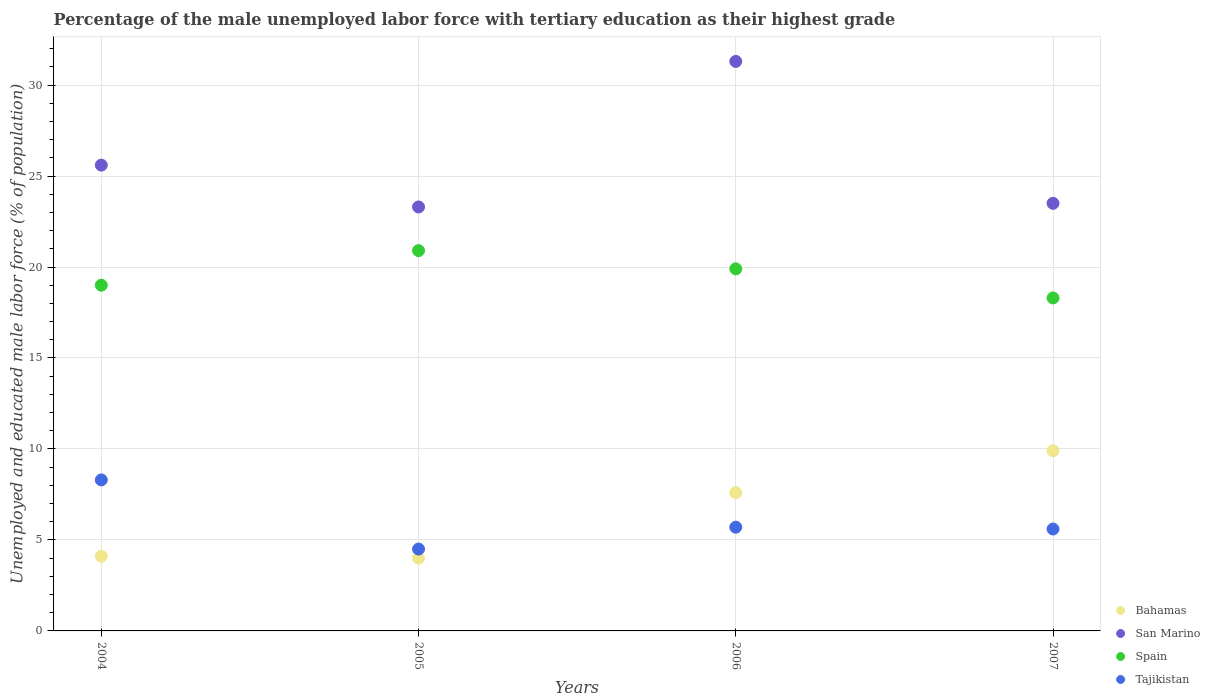What is the percentage of the unemployed male labor force with tertiary education in Spain in 2004?
Offer a very short reply. 19. Across all years, what is the maximum percentage of the unemployed male labor force with tertiary education in Bahamas?
Offer a very short reply. 9.9. Across all years, what is the minimum percentage of the unemployed male labor force with tertiary education in Spain?
Provide a short and direct response. 18.3. In which year was the percentage of the unemployed male labor force with tertiary education in Spain minimum?
Your response must be concise. 2007. What is the total percentage of the unemployed male labor force with tertiary education in San Marino in the graph?
Your answer should be compact. 103.7. What is the difference between the percentage of the unemployed male labor force with tertiary education in Spain in 2004 and that in 2006?
Offer a terse response. -0.9. What is the difference between the percentage of the unemployed male labor force with tertiary education in San Marino in 2006 and the percentage of the unemployed male labor force with tertiary education in Bahamas in 2005?
Ensure brevity in your answer.  27.3. What is the average percentage of the unemployed male labor force with tertiary education in San Marino per year?
Provide a succinct answer. 25.92. In the year 2005, what is the difference between the percentage of the unemployed male labor force with tertiary education in San Marino and percentage of the unemployed male labor force with tertiary education in Spain?
Offer a terse response. 2.4. In how many years, is the percentage of the unemployed male labor force with tertiary education in Tajikistan greater than 31 %?
Keep it short and to the point. 0. What is the ratio of the percentage of the unemployed male labor force with tertiary education in Spain in 2004 to that in 2006?
Ensure brevity in your answer.  0.95. What is the difference between the highest and the second highest percentage of the unemployed male labor force with tertiary education in Tajikistan?
Make the answer very short. 2.6. What is the difference between the highest and the lowest percentage of the unemployed male labor force with tertiary education in San Marino?
Provide a short and direct response. 8. In how many years, is the percentage of the unemployed male labor force with tertiary education in San Marino greater than the average percentage of the unemployed male labor force with tertiary education in San Marino taken over all years?
Give a very brief answer. 1. Is the percentage of the unemployed male labor force with tertiary education in San Marino strictly less than the percentage of the unemployed male labor force with tertiary education in Bahamas over the years?
Offer a terse response. No. How many dotlines are there?
Offer a very short reply. 4. Does the graph contain any zero values?
Ensure brevity in your answer.  No. Does the graph contain grids?
Your answer should be very brief. Yes. Where does the legend appear in the graph?
Your answer should be very brief. Bottom right. How are the legend labels stacked?
Provide a short and direct response. Vertical. What is the title of the graph?
Provide a short and direct response. Percentage of the male unemployed labor force with tertiary education as their highest grade. What is the label or title of the X-axis?
Give a very brief answer. Years. What is the label or title of the Y-axis?
Provide a short and direct response. Unemployed and educated male labor force (% of population). What is the Unemployed and educated male labor force (% of population) of Bahamas in 2004?
Ensure brevity in your answer.  4.1. What is the Unemployed and educated male labor force (% of population) in San Marino in 2004?
Your answer should be compact. 25.6. What is the Unemployed and educated male labor force (% of population) of Spain in 2004?
Make the answer very short. 19. What is the Unemployed and educated male labor force (% of population) of Tajikistan in 2004?
Offer a very short reply. 8.3. What is the Unemployed and educated male labor force (% of population) in Bahamas in 2005?
Give a very brief answer. 4. What is the Unemployed and educated male labor force (% of population) in San Marino in 2005?
Ensure brevity in your answer.  23.3. What is the Unemployed and educated male labor force (% of population) in Spain in 2005?
Provide a succinct answer. 20.9. What is the Unemployed and educated male labor force (% of population) of Tajikistan in 2005?
Ensure brevity in your answer.  4.5. What is the Unemployed and educated male labor force (% of population) of Bahamas in 2006?
Keep it short and to the point. 7.6. What is the Unemployed and educated male labor force (% of population) in San Marino in 2006?
Give a very brief answer. 31.3. What is the Unemployed and educated male labor force (% of population) in Spain in 2006?
Your answer should be very brief. 19.9. What is the Unemployed and educated male labor force (% of population) of Tajikistan in 2006?
Your answer should be very brief. 5.7. What is the Unemployed and educated male labor force (% of population) in Bahamas in 2007?
Provide a succinct answer. 9.9. What is the Unemployed and educated male labor force (% of population) of San Marino in 2007?
Provide a short and direct response. 23.5. What is the Unemployed and educated male labor force (% of population) of Spain in 2007?
Ensure brevity in your answer.  18.3. What is the Unemployed and educated male labor force (% of population) of Tajikistan in 2007?
Your response must be concise. 5.6. Across all years, what is the maximum Unemployed and educated male labor force (% of population) of Bahamas?
Give a very brief answer. 9.9. Across all years, what is the maximum Unemployed and educated male labor force (% of population) of San Marino?
Make the answer very short. 31.3. Across all years, what is the maximum Unemployed and educated male labor force (% of population) in Spain?
Keep it short and to the point. 20.9. Across all years, what is the maximum Unemployed and educated male labor force (% of population) of Tajikistan?
Ensure brevity in your answer.  8.3. Across all years, what is the minimum Unemployed and educated male labor force (% of population) in Bahamas?
Offer a terse response. 4. Across all years, what is the minimum Unemployed and educated male labor force (% of population) in San Marino?
Ensure brevity in your answer.  23.3. Across all years, what is the minimum Unemployed and educated male labor force (% of population) of Spain?
Ensure brevity in your answer.  18.3. Across all years, what is the minimum Unemployed and educated male labor force (% of population) in Tajikistan?
Your answer should be compact. 4.5. What is the total Unemployed and educated male labor force (% of population) in Bahamas in the graph?
Offer a very short reply. 25.6. What is the total Unemployed and educated male labor force (% of population) in San Marino in the graph?
Provide a succinct answer. 103.7. What is the total Unemployed and educated male labor force (% of population) in Spain in the graph?
Ensure brevity in your answer.  78.1. What is the total Unemployed and educated male labor force (% of population) in Tajikistan in the graph?
Make the answer very short. 24.1. What is the difference between the Unemployed and educated male labor force (% of population) of San Marino in 2004 and that in 2005?
Your answer should be very brief. 2.3. What is the difference between the Unemployed and educated male labor force (% of population) in Bahamas in 2004 and that in 2006?
Your answer should be compact. -3.5. What is the difference between the Unemployed and educated male labor force (% of population) in San Marino in 2004 and that in 2006?
Keep it short and to the point. -5.7. What is the difference between the Unemployed and educated male labor force (% of population) of Tajikistan in 2004 and that in 2006?
Keep it short and to the point. 2.6. What is the difference between the Unemployed and educated male labor force (% of population) of Tajikistan in 2004 and that in 2007?
Give a very brief answer. 2.7. What is the difference between the Unemployed and educated male labor force (% of population) of San Marino in 2005 and that in 2006?
Offer a terse response. -8. What is the difference between the Unemployed and educated male labor force (% of population) in Spain in 2005 and that in 2006?
Make the answer very short. 1. What is the difference between the Unemployed and educated male labor force (% of population) of Tajikistan in 2005 and that in 2006?
Your response must be concise. -1.2. What is the difference between the Unemployed and educated male labor force (% of population) of Tajikistan in 2005 and that in 2007?
Ensure brevity in your answer.  -1.1. What is the difference between the Unemployed and educated male labor force (% of population) of Bahamas in 2006 and that in 2007?
Offer a terse response. -2.3. What is the difference between the Unemployed and educated male labor force (% of population) of San Marino in 2006 and that in 2007?
Your answer should be compact. 7.8. What is the difference between the Unemployed and educated male labor force (% of population) of Spain in 2006 and that in 2007?
Provide a short and direct response. 1.6. What is the difference between the Unemployed and educated male labor force (% of population) in Tajikistan in 2006 and that in 2007?
Keep it short and to the point. 0.1. What is the difference between the Unemployed and educated male labor force (% of population) of Bahamas in 2004 and the Unemployed and educated male labor force (% of population) of San Marino in 2005?
Offer a terse response. -19.2. What is the difference between the Unemployed and educated male labor force (% of population) in Bahamas in 2004 and the Unemployed and educated male labor force (% of population) in Spain in 2005?
Keep it short and to the point. -16.8. What is the difference between the Unemployed and educated male labor force (% of population) in San Marino in 2004 and the Unemployed and educated male labor force (% of population) in Spain in 2005?
Your response must be concise. 4.7. What is the difference between the Unemployed and educated male labor force (% of population) in San Marino in 2004 and the Unemployed and educated male labor force (% of population) in Tajikistan in 2005?
Ensure brevity in your answer.  21.1. What is the difference between the Unemployed and educated male labor force (% of population) of Spain in 2004 and the Unemployed and educated male labor force (% of population) of Tajikistan in 2005?
Make the answer very short. 14.5. What is the difference between the Unemployed and educated male labor force (% of population) of Bahamas in 2004 and the Unemployed and educated male labor force (% of population) of San Marino in 2006?
Give a very brief answer. -27.2. What is the difference between the Unemployed and educated male labor force (% of population) in Bahamas in 2004 and the Unemployed and educated male labor force (% of population) in Spain in 2006?
Provide a short and direct response. -15.8. What is the difference between the Unemployed and educated male labor force (% of population) in Bahamas in 2004 and the Unemployed and educated male labor force (% of population) in Tajikistan in 2006?
Keep it short and to the point. -1.6. What is the difference between the Unemployed and educated male labor force (% of population) of San Marino in 2004 and the Unemployed and educated male labor force (% of population) of Spain in 2006?
Give a very brief answer. 5.7. What is the difference between the Unemployed and educated male labor force (% of population) in Bahamas in 2004 and the Unemployed and educated male labor force (% of population) in San Marino in 2007?
Provide a succinct answer. -19.4. What is the difference between the Unemployed and educated male labor force (% of population) in Bahamas in 2004 and the Unemployed and educated male labor force (% of population) in Spain in 2007?
Your answer should be very brief. -14.2. What is the difference between the Unemployed and educated male labor force (% of population) of Bahamas in 2004 and the Unemployed and educated male labor force (% of population) of Tajikistan in 2007?
Make the answer very short. -1.5. What is the difference between the Unemployed and educated male labor force (% of population) in San Marino in 2004 and the Unemployed and educated male labor force (% of population) in Tajikistan in 2007?
Offer a very short reply. 20. What is the difference between the Unemployed and educated male labor force (% of population) of Spain in 2004 and the Unemployed and educated male labor force (% of population) of Tajikistan in 2007?
Provide a succinct answer. 13.4. What is the difference between the Unemployed and educated male labor force (% of population) of Bahamas in 2005 and the Unemployed and educated male labor force (% of population) of San Marino in 2006?
Ensure brevity in your answer.  -27.3. What is the difference between the Unemployed and educated male labor force (% of population) in Bahamas in 2005 and the Unemployed and educated male labor force (% of population) in Spain in 2006?
Give a very brief answer. -15.9. What is the difference between the Unemployed and educated male labor force (% of population) in Bahamas in 2005 and the Unemployed and educated male labor force (% of population) in Tajikistan in 2006?
Your answer should be compact. -1.7. What is the difference between the Unemployed and educated male labor force (% of population) of San Marino in 2005 and the Unemployed and educated male labor force (% of population) of Spain in 2006?
Offer a very short reply. 3.4. What is the difference between the Unemployed and educated male labor force (% of population) of San Marino in 2005 and the Unemployed and educated male labor force (% of population) of Tajikistan in 2006?
Provide a short and direct response. 17.6. What is the difference between the Unemployed and educated male labor force (% of population) of Spain in 2005 and the Unemployed and educated male labor force (% of population) of Tajikistan in 2006?
Provide a succinct answer. 15.2. What is the difference between the Unemployed and educated male labor force (% of population) of Bahamas in 2005 and the Unemployed and educated male labor force (% of population) of San Marino in 2007?
Offer a very short reply. -19.5. What is the difference between the Unemployed and educated male labor force (% of population) of Bahamas in 2005 and the Unemployed and educated male labor force (% of population) of Spain in 2007?
Keep it short and to the point. -14.3. What is the difference between the Unemployed and educated male labor force (% of population) in Bahamas in 2005 and the Unemployed and educated male labor force (% of population) in Tajikistan in 2007?
Keep it short and to the point. -1.6. What is the difference between the Unemployed and educated male labor force (% of population) in San Marino in 2005 and the Unemployed and educated male labor force (% of population) in Tajikistan in 2007?
Make the answer very short. 17.7. What is the difference between the Unemployed and educated male labor force (% of population) in Spain in 2005 and the Unemployed and educated male labor force (% of population) in Tajikistan in 2007?
Offer a terse response. 15.3. What is the difference between the Unemployed and educated male labor force (% of population) of Bahamas in 2006 and the Unemployed and educated male labor force (% of population) of San Marino in 2007?
Your answer should be very brief. -15.9. What is the difference between the Unemployed and educated male labor force (% of population) in Bahamas in 2006 and the Unemployed and educated male labor force (% of population) in Tajikistan in 2007?
Offer a very short reply. 2. What is the difference between the Unemployed and educated male labor force (% of population) in San Marino in 2006 and the Unemployed and educated male labor force (% of population) in Tajikistan in 2007?
Keep it short and to the point. 25.7. What is the average Unemployed and educated male labor force (% of population) in Bahamas per year?
Offer a very short reply. 6.4. What is the average Unemployed and educated male labor force (% of population) of San Marino per year?
Your response must be concise. 25.93. What is the average Unemployed and educated male labor force (% of population) in Spain per year?
Provide a succinct answer. 19.52. What is the average Unemployed and educated male labor force (% of population) of Tajikistan per year?
Offer a very short reply. 6.03. In the year 2004, what is the difference between the Unemployed and educated male labor force (% of population) in Bahamas and Unemployed and educated male labor force (% of population) in San Marino?
Give a very brief answer. -21.5. In the year 2004, what is the difference between the Unemployed and educated male labor force (% of population) of Bahamas and Unemployed and educated male labor force (% of population) of Spain?
Make the answer very short. -14.9. In the year 2004, what is the difference between the Unemployed and educated male labor force (% of population) in Bahamas and Unemployed and educated male labor force (% of population) in Tajikistan?
Keep it short and to the point. -4.2. In the year 2004, what is the difference between the Unemployed and educated male labor force (% of population) in San Marino and Unemployed and educated male labor force (% of population) in Spain?
Provide a succinct answer. 6.6. In the year 2005, what is the difference between the Unemployed and educated male labor force (% of population) in Bahamas and Unemployed and educated male labor force (% of population) in San Marino?
Ensure brevity in your answer.  -19.3. In the year 2005, what is the difference between the Unemployed and educated male labor force (% of population) of Bahamas and Unemployed and educated male labor force (% of population) of Spain?
Make the answer very short. -16.9. In the year 2005, what is the difference between the Unemployed and educated male labor force (% of population) in San Marino and Unemployed and educated male labor force (% of population) in Tajikistan?
Your answer should be compact. 18.8. In the year 2005, what is the difference between the Unemployed and educated male labor force (% of population) of Spain and Unemployed and educated male labor force (% of population) of Tajikistan?
Give a very brief answer. 16.4. In the year 2006, what is the difference between the Unemployed and educated male labor force (% of population) in Bahamas and Unemployed and educated male labor force (% of population) in San Marino?
Give a very brief answer. -23.7. In the year 2006, what is the difference between the Unemployed and educated male labor force (% of population) of Bahamas and Unemployed and educated male labor force (% of population) of Tajikistan?
Your answer should be compact. 1.9. In the year 2006, what is the difference between the Unemployed and educated male labor force (% of population) of San Marino and Unemployed and educated male labor force (% of population) of Tajikistan?
Provide a short and direct response. 25.6. In the year 2006, what is the difference between the Unemployed and educated male labor force (% of population) in Spain and Unemployed and educated male labor force (% of population) in Tajikistan?
Offer a terse response. 14.2. In the year 2007, what is the difference between the Unemployed and educated male labor force (% of population) in Bahamas and Unemployed and educated male labor force (% of population) in San Marino?
Keep it short and to the point. -13.6. In the year 2007, what is the difference between the Unemployed and educated male labor force (% of population) in Bahamas and Unemployed and educated male labor force (% of population) in Spain?
Offer a very short reply. -8.4. In the year 2007, what is the difference between the Unemployed and educated male labor force (% of population) of San Marino and Unemployed and educated male labor force (% of population) of Spain?
Ensure brevity in your answer.  5.2. In the year 2007, what is the difference between the Unemployed and educated male labor force (% of population) in San Marino and Unemployed and educated male labor force (% of population) in Tajikistan?
Your response must be concise. 17.9. What is the ratio of the Unemployed and educated male labor force (% of population) in San Marino in 2004 to that in 2005?
Provide a short and direct response. 1.1. What is the ratio of the Unemployed and educated male labor force (% of population) of Spain in 2004 to that in 2005?
Give a very brief answer. 0.91. What is the ratio of the Unemployed and educated male labor force (% of population) in Tajikistan in 2004 to that in 2005?
Keep it short and to the point. 1.84. What is the ratio of the Unemployed and educated male labor force (% of population) in Bahamas in 2004 to that in 2006?
Keep it short and to the point. 0.54. What is the ratio of the Unemployed and educated male labor force (% of population) in San Marino in 2004 to that in 2006?
Keep it short and to the point. 0.82. What is the ratio of the Unemployed and educated male labor force (% of population) of Spain in 2004 to that in 2006?
Ensure brevity in your answer.  0.95. What is the ratio of the Unemployed and educated male labor force (% of population) of Tajikistan in 2004 to that in 2006?
Offer a terse response. 1.46. What is the ratio of the Unemployed and educated male labor force (% of population) in Bahamas in 2004 to that in 2007?
Offer a very short reply. 0.41. What is the ratio of the Unemployed and educated male labor force (% of population) in San Marino in 2004 to that in 2007?
Provide a succinct answer. 1.09. What is the ratio of the Unemployed and educated male labor force (% of population) of Spain in 2004 to that in 2007?
Your response must be concise. 1.04. What is the ratio of the Unemployed and educated male labor force (% of population) in Tajikistan in 2004 to that in 2007?
Provide a succinct answer. 1.48. What is the ratio of the Unemployed and educated male labor force (% of population) of Bahamas in 2005 to that in 2006?
Offer a very short reply. 0.53. What is the ratio of the Unemployed and educated male labor force (% of population) of San Marino in 2005 to that in 2006?
Your answer should be very brief. 0.74. What is the ratio of the Unemployed and educated male labor force (% of population) in Spain in 2005 to that in 2006?
Your answer should be very brief. 1.05. What is the ratio of the Unemployed and educated male labor force (% of population) in Tajikistan in 2005 to that in 2006?
Ensure brevity in your answer.  0.79. What is the ratio of the Unemployed and educated male labor force (% of population) in Bahamas in 2005 to that in 2007?
Ensure brevity in your answer.  0.4. What is the ratio of the Unemployed and educated male labor force (% of population) of Spain in 2005 to that in 2007?
Give a very brief answer. 1.14. What is the ratio of the Unemployed and educated male labor force (% of population) of Tajikistan in 2005 to that in 2007?
Provide a short and direct response. 0.8. What is the ratio of the Unemployed and educated male labor force (% of population) of Bahamas in 2006 to that in 2007?
Offer a terse response. 0.77. What is the ratio of the Unemployed and educated male labor force (% of population) in San Marino in 2006 to that in 2007?
Your response must be concise. 1.33. What is the ratio of the Unemployed and educated male labor force (% of population) in Spain in 2006 to that in 2007?
Give a very brief answer. 1.09. What is the ratio of the Unemployed and educated male labor force (% of population) in Tajikistan in 2006 to that in 2007?
Provide a short and direct response. 1.02. What is the difference between the highest and the second highest Unemployed and educated male labor force (% of population) of Bahamas?
Keep it short and to the point. 2.3. What is the difference between the highest and the second highest Unemployed and educated male labor force (% of population) in San Marino?
Offer a terse response. 5.7. What is the difference between the highest and the second highest Unemployed and educated male labor force (% of population) in Tajikistan?
Provide a short and direct response. 2.6. What is the difference between the highest and the lowest Unemployed and educated male labor force (% of population) of Tajikistan?
Give a very brief answer. 3.8. 